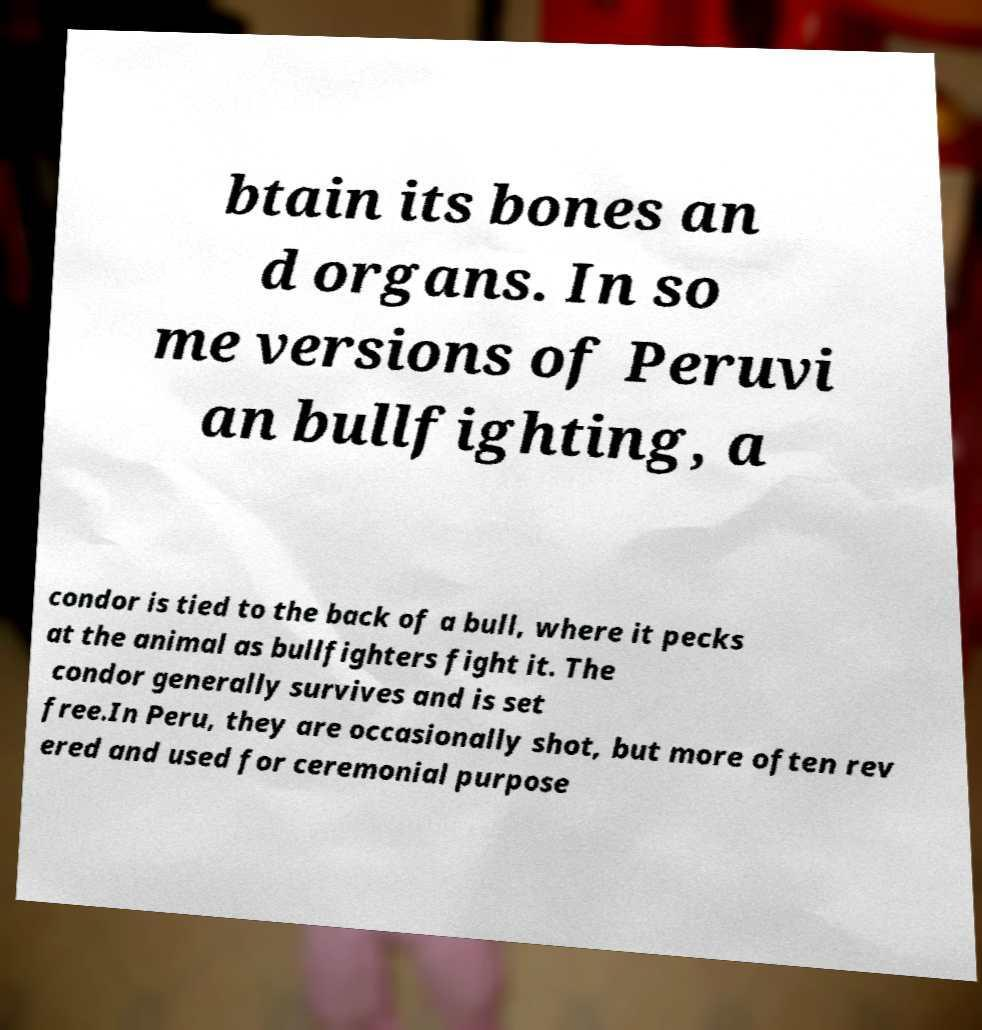Could you assist in decoding the text presented in this image and type it out clearly? btain its bones an d organs. In so me versions of Peruvi an bullfighting, a condor is tied to the back of a bull, where it pecks at the animal as bullfighters fight it. The condor generally survives and is set free.In Peru, they are occasionally shot, but more often rev ered and used for ceremonial purpose 